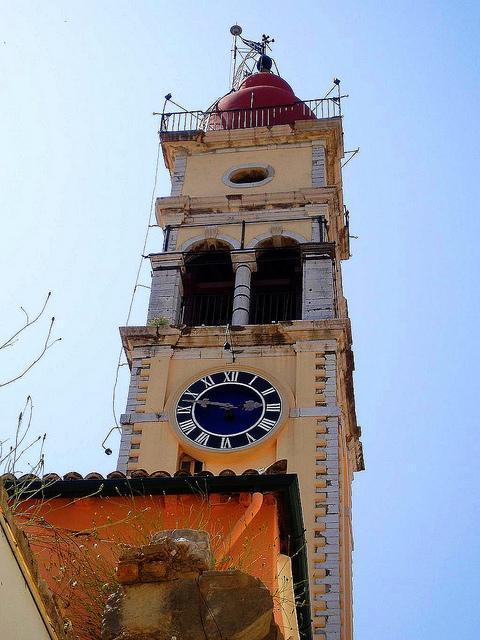How many people on the train are sitting next to a window that opens?
Give a very brief answer. 0. 